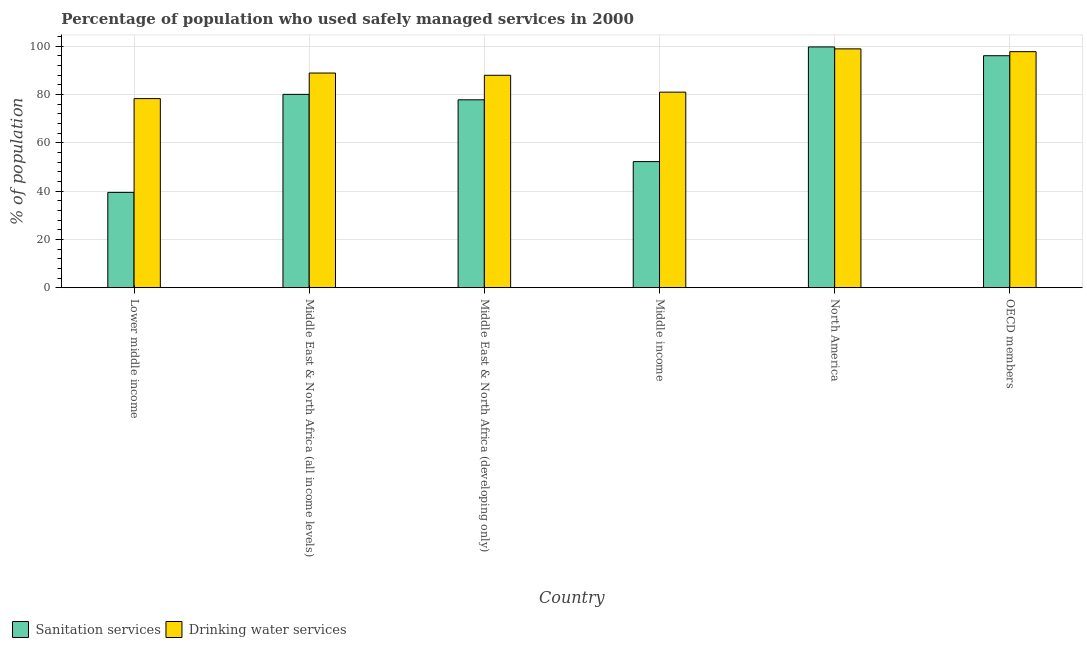How many different coloured bars are there?
Provide a short and direct response. 2. How many groups of bars are there?
Your response must be concise. 6. Are the number of bars per tick equal to the number of legend labels?
Offer a terse response. Yes. How many bars are there on the 1st tick from the left?
Your answer should be very brief. 2. What is the label of the 4th group of bars from the left?
Provide a short and direct response. Middle income. What is the percentage of population who used drinking water services in OECD members?
Keep it short and to the point. 97.74. Across all countries, what is the maximum percentage of population who used sanitation services?
Keep it short and to the point. 99.71. Across all countries, what is the minimum percentage of population who used drinking water services?
Your answer should be very brief. 78.31. In which country was the percentage of population who used drinking water services minimum?
Offer a terse response. Lower middle income. What is the total percentage of population who used sanitation services in the graph?
Your answer should be compact. 445.3. What is the difference between the percentage of population who used drinking water services in Middle East & North Africa (developing only) and that in OECD members?
Give a very brief answer. -9.79. What is the difference between the percentage of population who used drinking water services in OECD members and the percentage of population who used sanitation services in North America?
Your answer should be compact. -1.96. What is the average percentage of population who used sanitation services per country?
Give a very brief answer. 74.22. What is the difference between the percentage of population who used sanitation services and percentage of population who used drinking water services in Lower middle income?
Offer a terse response. -38.85. What is the ratio of the percentage of population who used sanitation services in Lower middle income to that in Middle income?
Provide a succinct answer. 0.76. Is the difference between the percentage of population who used drinking water services in Lower middle income and OECD members greater than the difference between the percentage of population who used sanitation services in Lower middle income and OECD members?
Provide a succinct answer. Yes. What is the difference between the highest and the second highest percentage of population who used drinking water services?
Ensure brevity in your answer.  1.15. What is the difference between the highest and the lowest percentage of population who used sanitation services?
Ensure brevity in your answer.  60.25. In how many countries, is the percentage of population who used drinking water services greater than the average percentage of population who used drinking water services taken over all countries?
Offer a terse response. 3. Is the sum of the percentage of population who used sanitation services in Middle income and North America greater than the maximum percentage of population who used drinking water services across all countries?
Offer a very short reply. Yes. What does the 1st bar from the left in Middle East & North Africa (all income levels) represents?
Offer a terse response. Sanitation services. What does the 2nd bar from the right in Middle income represents?
Offer a terse response. Sanitation services. How many bars are there?
Ensure brevity in your answer.  12. How many countries are there in the graph?
Give a very brief answer. 6. What is the difference between two consecutive major ticks on the Y-axis?
Keep it short and to the point. 20. Are the values on the major ticks of Y-axis written in scientific E-notation?
Provide a short and direct response. No. Does the graph contain any zero values?
Keep it short and to the point. No. Does the graph contain grids?
Keep it short and to the point. Yes. Where does the legend appear in the graph?
Offer a very short reply. Bottom left. How are the legend labels stacked?
Give a very brief answer. Horizontal. What is the title of the graph?
Give a very brief answer. Percentage of population who used safely managed services in 2000. Does "Commercial service exports" appear as one of the legend labels in the graph?
Offer a terse response. No. What is the label or title of the Y-axis?
Ensure brevity in your answer.  % of population. What is the % of population in Sanitation services in Lower middle income?
Make the answer very short. 39.46. What is the % of population of Drinking water services in Lower middle income?
Make the answer very short. 78.31. What is the % of population of Sanitation services in Middle East & North Africa (all income levels)?
Your response must be concise. 80.05. What is the % of population of Drinking water services in Middle East & North Africa (all income levels)?
Make the answer very short. 88.89. What is the % of population of Sanitation services in Middle East & North Africa (developing only)?
Your answer should be very brief. 77.81. What is the % of population in Drinking water services in Middle East & North Africa (developing only)?
Offer a very short reply. 87.96. What is the % of population in Sanitation services in Middle income?
Your answer should be very brief. 52.21. What is the % of population of Drinking water services in Middle income?
Offer a terse response. 80.97. What is the % of population of Sanitation services in North America?
Your answer should be compact. 99.71. What is the % of population in Drinking water services in North America?
Your response must be concise. 98.9. What is the % of population in Sanitation services in OECD members?
Ensure brevity in your answer.  96.06. What is the % of population in Drinking water services in OECD members?
Your response must be concise. 97.74. Across all countries, what is the maximum % of population in Sanitation services?
Give a very brief answer. 99.71. Across all countries, what is the maximum % of population of Drinking water services?
Your answer should be very brief. 98.9. Across all countries, what is the minimum % of population in Sanitation services?
Ensure brevity in your answer.  39.46. Across all countries, what is the minimum % of population of Drinking water services?
Provide a succinct answer. 78.31. What is the total % of population of Sanitation services in the graph?
Your answer should be very brief. 445.3. What is the total % of population of Drinking water services in the graph?
Provide a short and direct response. 532.76. What is the difference between the % of population of Sanitation services in Lower middle income and that in Middle East & North Africa (all income levels)?
Provide a short and direct response. -40.6. What is the difference between the % of population in Drinking water services in Lower middle income and that in Middle East & North Africa (all income levels)?
Your response must be concise. -10.58. What is the difference between the % of population in Sanitation services in Lower middle income and that in Middle East & North Africa (developing only)?
Offer a terse response. -38.35. What is the difference between the % of population in Drinking water services in Lower middle income and that in Middle East & North Africa (developing only)?
Provide a short and direct response. -9.65. What is the difference between the % of population in Sanitation services in Lower middle income and that in Middle income?
Keep it short and to the point. -12.75. What is the difference between the % of population in Drinking water services in Lower middle income and that in Middle income?
Provide a short and direct response. -2.67. What is the difference between the % of population in Sanitation services in Lower middle income and that in North America?
Provide a short and direct response. -60.25. What is the difference between the % of population of Drinking water services in Lower middle income and that in North America?
Keep it short and to the point. -20.59. What is the difference between the % of population in Sanitation services in Lower middle income and that in OECD members?
Your answer should be very brief. -56.61. What is the difference between the % of population of Drinking water services in Lower middle income and that in OECD members?
Make the answer very short. -19.44. What is the difference between the % of population of Sanitation services in Middle East & North Africa (all income levels) and that in Middle East & North Africa (developing only)?
Keep it short and to the point. 2.25. What is the difference between the % of population of Drinking water services in Middle East & North Africa (all income levels) and that in Middle East & North Africa (developing only)?
Your response must be concise. 0.93. What is the difference between the % of population in Sanitation services in Middle East & North Africa (all income levels) and that in Middle income?
Offer a very short reply. 27.85. What is the difference between the % of population of Drinking water services in Middle East & North Africa (all income levels) and that in Middle income?
Offer a terse response. 7.91. What is the difference between the % of population of Sanitation services in Middle East & North Africa (all income levels) and that in North America?
Provide a succinct answer. -19.65. What is the difference between the % of population of Drinking water services in Middle East & North Africa (all income levels) and that in North America?
Offer a terse response. -10.01. What is the difference between the % of population of Sanitation services in Middle East & North Africa (all income levels) and that in OECD members?
Provide a short and direct response. -16.01. What is the difference between the % of population of Drinking water services in Middle East & North Africa (all income levels) and that in OECD members?
Keep it short and to the point. -8.86. What is the difference between the % of population in Sanitation services in Middle East & North Africa (developing only) and that in Middle income?
Provide a short and direct response. 25.6. What is the difference between the % of population in Drinking water services in Middle East & North Africa (developing only) and that in Middle income?
Offer a very short reply. 6.98. What is the difference between the % of population of Sanitation services in Middle East & North Africa (developing only) and that in North America?
Your answer should be compact. -21.9. What is the difference between the % of population in Drinking water services in Middle East & North Africa (developing only) and that in North America?
Keep it short and to the point. -10.94. What is the difference between the % of population of Sanitation services in Middle East & North Africa (developing only) and that in OECD members?
Give a very brief answer. -18.26. What is the difference between the % of population of Drinking water services in Middle East & North Africa (developing only) and that in OECD members?
Provide a succinct answer. -9.79. What is the difference between the % of population of Sanitation services in Middle income and that in North America?
Your answer should be very brief. -47.5. What is the difference between the % of population of Drinking water services in Middle income and that in North America?
Provide a short and direct response. -17.92. What is the difference between the % of population of Sanitation services in Middle income and that in OECD members?
Your answer should be very brief. -43.86. What is the difference between the % of population of Drinking water services in Middle income and that in OECD members?
Provide a short and direct response. -16.77. What is the difference between the % of population in Sanitation services in North America and that in OECD members?
Give a very brief answer. 3.65. What is the difference between the % of population of Drinking water services in North America and that in OECD members?
Make the answer very short. 1.15. What is the difference between the % of population of Sanitation services in Lower middle income and the % of population of Drinking water services in Middle East & North Africa (all income levels)?
Your response must be concise. -49.43. What is the difference between the % of population of Sanitation services in Lower middle income and the % of population of Drinking water services in Middle East & North Africa (developing only)?
Offer a very short reply. -48.5. What is the difference between the % of population in Sanitation services in Lower middle income and the % of population in Drinking water services in Middle income?
Offer a very short reply. -41.52. What is the difference between the % of population in Sanitation services in Lower middle income and the % of population in Drinking water services in North America?
Keep it short and to the point. -59.44. What is the difference between the % of population in Sanitation services in Lower middle income and the % of population in Drinking water services in OECD members?
Your answer should be very brief. -58.29. What is the difference between the % of population in Sanitation services in Middle East & North Africa (all income levels) and the % of population in Drinking water services in Middle East & North Africa (developing only)?
Your response must be concise. -7.9. What is the difference between the % of population of Sanitation services in Middle East & North Africa (all income levels) and the % of population of Drinking water services in Middle income?
Ensure brevity in your answer.  -0.92. What is the difference between the % of population in Sanitation services in Middle East & North Africa (all income levels) and the % of population in Drinking water services in North America?
Give a very brief answer. -18.84. What is the difference between the % of population in Sanitation services in Middle East & North Africa (all income levels) and the % of population in Drinking water services in OECD members?
Give a very brief answer. -17.69. What is the difference between the % of population in Sanitation services in Middle East & North Africa (developing only) and the % of population in Drinking water services in Middle income?
Make the answer very short. -3.17. What is the difference between the % of population in Sanitation services in Middle East & North Africa (developing only) and the % of population in Drinking water services in North America?
Make the answer very short. -21.09. What is the difference between the % of population in Sanitation services in Middle East & North Africa (developing only) and the % of population in Drinking water services in OECD members?
Ensure brevity in your answer.  -19.94. What is the difference between the % of population of Sanitation services in Middle income and the % of population of Drinking water services in North America?
Keep it short and to the point. -46.69. What is the difference between the % of population in Sanitation services in Middle income and the % of population in Drinking water services in OECD members?
Your answer should be very brief. -45.54. What is the difference between the % of population in Sanitation services in North America and the % of population in Drinking water services in OECD members?
Keep it short and to the point. 1.97. What is the average % of population in Sanitation services per country?
Your response must be concise. 74.22. What is the average % of population in Drinking water services per country?
Ensure brevity in your answer.  88.79. What is the difference between the % of population of Sanitation services and % of population of Drinking water services in Lower middle income?
Give a very brief answer. -38.85. What is the difference between the % of population in Sanitation services and % of population in Drinking water services in Middle East & North Africa (all income levels)?
Keep it short and to the point. -8.83. What is the difference between the % of population of Sanitation services and % of population of Drinking water services in Middle East & North Africa (developing only)?
Keep it short and to the point. -10.15. What is the difference between the % of population in Sanitation services and % of population in Drinking water services in Middle income?
Keep it short and to the point. -28.77. What is the difference between the % of population in Sanitation services and % of population in Drinking water services in North America?
Your answer should be compact. 0.81. What is the difference between the % of population in Sanitation services and % of population in Drinking water services in OECD members?
Your answer should be compact. -1.68. What is the ratio of the % of population in Sanitation services in Lower middle income to that in Middle East & North Africa (all income levels)?
Your answer should be compact. 0.49. What is the ratio of the % of population in Drinking water services in Lower middle income to that in Middle East & North Africa (all income levels)?
Keep it short and to the point. 0.88. What is the ratio of the % of population of Sanitation services in Lower middle income to that in Middle East & North Africa (developing only)?
Give a very brief answer. 0.51. What is the ratio of the % of population in Drinking water services in Lower middle income to that in Middle East & North Africa (developing only)?
Ensure brevity in your answer.  0.89. What is the ratio of the % of population in Sanitation services in Lower middle income to that in Middle income?
Give a very brief answer. 0.76. What is the ratio of the % of population of Drinking water services in Lower middle income to that in Middle income?
Your response must be concise. 0.97. What is the ratio of the % of population in Sanitation services in Lower middle income to that in North America?
Ensure brevity in your answer.  0.4. What is the ratio of the % of population in Drinking water services in Lower middle income to that in North America?
Offer a terse response. 0.79. What is the ratio of the % of population of Sanitation services in Lower middle income to that in OECD members?
Make the answer very short. 0.41. What is the ratio of the % of population in Drinking water services in Lower middle income to that in OECD members?
Make the answer very short. 0.8. What is the ratio of the % of population of Sanitation services in Middle East & North Africa (all income levels) to that in Middle East & North Africa (developing only)?
Provide a short and direct response. 1.03. What is the ratio of the % of population in Drinking water services in Middle East & North Africa (all income levels) to that in Middle East & North Africa (developing only)?
Give a very brief answer. 1.01. What is the ratio of the % of population of Sanitation services in Middle East & North Africa (all income levels) to that in Middle income?
Make the answer very short. 1.53. What is the ratio of the % of population in Drinking water services in Middle East & North Africa (all income levels) to that in Middle income?
Provide a short and direct response. 1.1. What is the ratio of the % of population of Sanitation services in Middle East & North Africa (all income levels) to that in North America?
Give a very brief answer. 0.8. What is the ratio of the % of population of Drinking water services in Middle East & North Africa (all income levels) to that in North America?
Offer a terse response. 0.9. What is the ratio of the % of population in Sanitation services in Middle East & North Africa (all income levels) to that in OECD members?
Give a very brief answer. 0.83. What is the ratio of the % of population of Drinking water services in Middle East & North Africa (all income levels) to that in OECD members?
Your response must be concise. 0.91. What is the ratio of the % of population in Sanitation services in Middle East & North Africa (developing only) to that in Middle income?
Offer a terse response. 1.49. What is the ratio of the % of population in Drinking water services in Middle East & North Africa (developing only) to that in Middle income?
Offer a terse response. 1.09. What is the ratio of the % of population of Sanitation services in Middle East & North Africa (developing only) to that in North America?
Keep it short and to the point. 0.78. What is the ratio of the % of population of Drinking water services in Middle East & North Africa (developing only) to that in North America?
Your response must be concise. 0.89. What is the ratio of the % of population in Sanitation services in Middle East & North Africa (developing only) to that in OECD members?
Provide a succinct answer. 0.81. What is the ratio of the % of population in Drinking water services in Middle East & North Africa (developing only) to that in OECD members?
Your answer should be compact. 0.9. What is the ratio of the % of population of Sanitation services in Middle income to that in North America?
Offer a very short reply. 0.52. What is the ratio of the % of population of Drinking water services in Middle income to that in North America?
Your response must be concise. 0.82. What is the ratio of the % of population of Sanitation services in Middle income to that in OECD members?
Ensure brevity in your answer.  0.54. What is the ratio of the % of population of Drinking water services in Middle income to that in OECD members?
Offer a terse response. 0.83. What is the ratio of the % of population in Sanitation services in North America to that in OECD members?
Your response must be concise. 1.04. What is the ratio of the % of population in Drinking water services in North America to that in OECD members?
Provide a short and direct response. 1.01. What is the difference between the highest and the second highest % of population in Sanitation services?
Provide a short and direct response. 3.65. What is the difference between the highest and the second highest % of population of Drinking water services?
Make the answer very short. 1.15. What is the difference between the highest and the lowest % of population in Sanitation services?
Provide a short and direct response. 60.25. What is the difference between the highest and the lowest % of population of Drinking water services?
Provide a short and direct response. 20.59. 